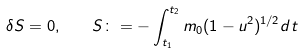<formula> <loc_0><loc_0><loc_500><loc_500>\delta S = 0 , \text { \ \ } S \colon = - \int _ { t _ { 1 } } ^ { t _ { 2 } } m _ { 0 } ( 1 - u ^ { 2 } ) ^ { 1 / 2 } d t</formula> 